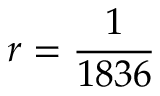<formula> <loc_0><loc_0><loc_500><loc_500>r = \frac { 1 } { 1 8 3 6 }</formula> 